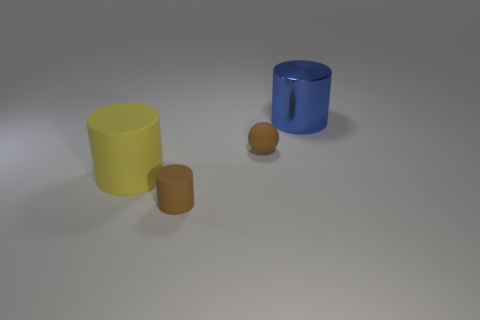Add 3 yellow things. How many objects exist? 7 Subtract all big cylinders. How many cylinders are left? 1 Subtract all yellow cylinders. How many cylinders are left? 2 Subtract all green spheres. How many yellow cylinders are left? 1 Subtract all brown spheres. Subtract all tiny brown things. How many objects are left? 1 Add 4 metallic objects. How many metallic objects are left? 5 Add 1 large blue cylinders. How many large blue cylinders exist? 2 Subtract 0 purple balls. How many objects are left? 4 Subtract all cylinders. How many objects are left? 1 Subtract 1 cylinders. How many cylinders are left? 2 